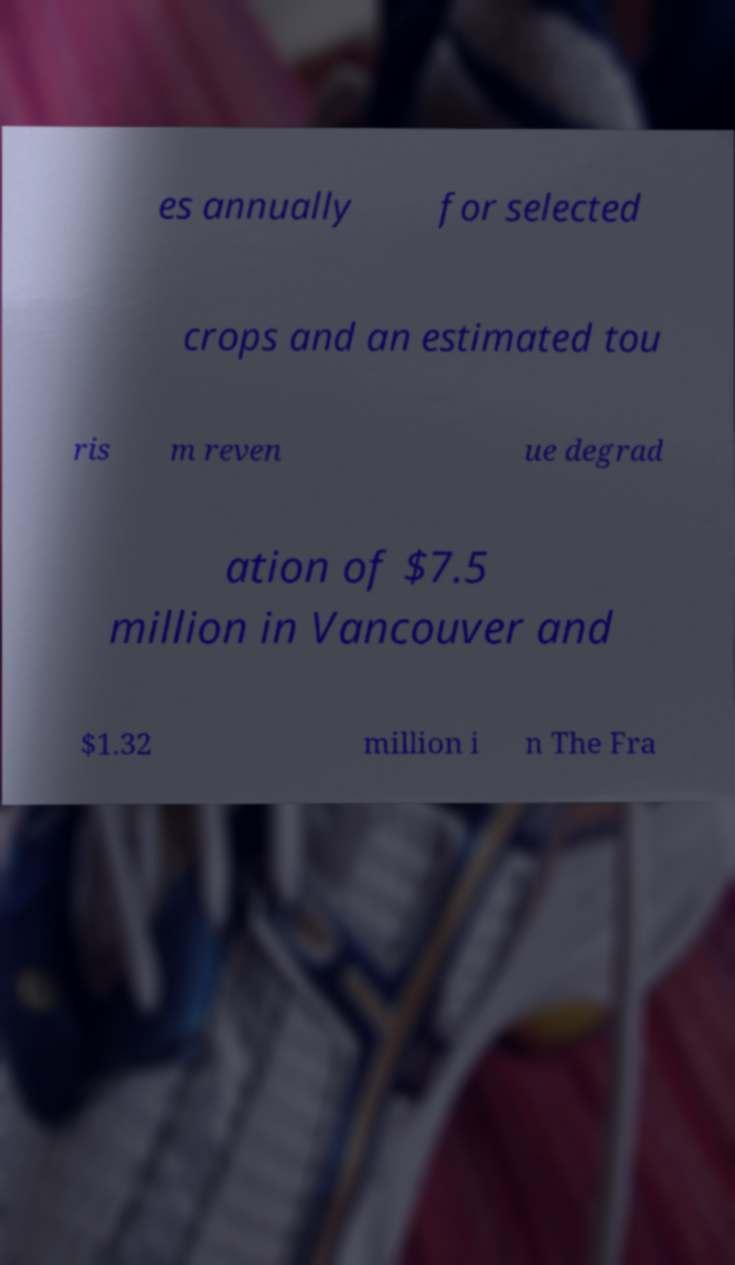There's text embedded in this image that I need extracted. Can you transcribe it verbatim? es annually for selected crops and an estimated tou ris m reven ue degrad ation of $7.5 million in Vancouver and $1.32 million i n The Fra 